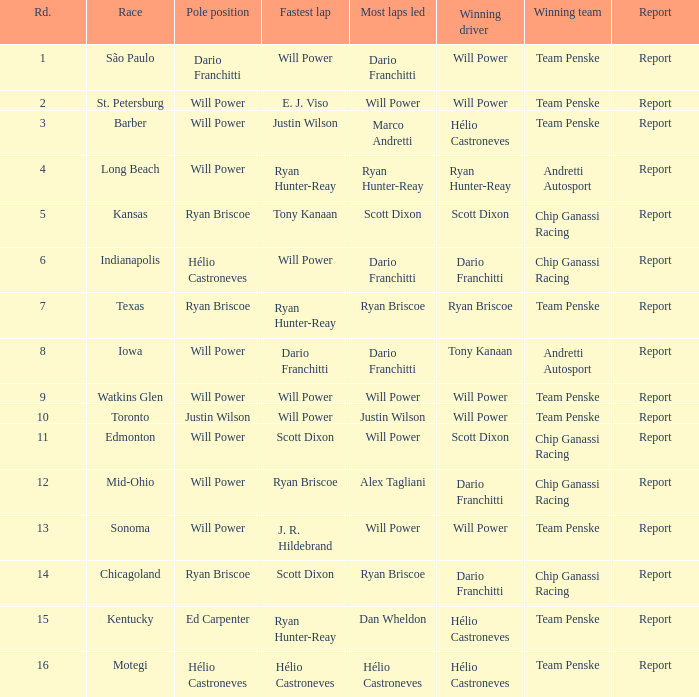What is the summary of races in which will power secured both pole position and the fastest lap? Report. 